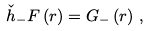<formula> <loc_0><loc_0><loc_500><loc_500>\check { h } _ { - } F \left ( r \right ) = G _ { - } \left ( r \right ) \, ,</formula> 